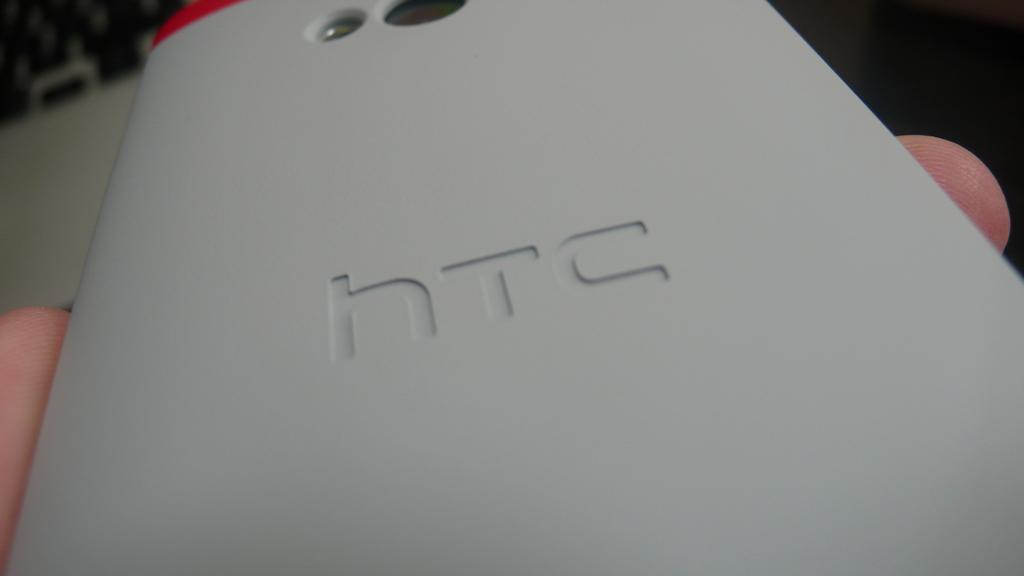<image>
Write a terse but informative summary of the picture. A hand holding a light gray HTC cell phone. 